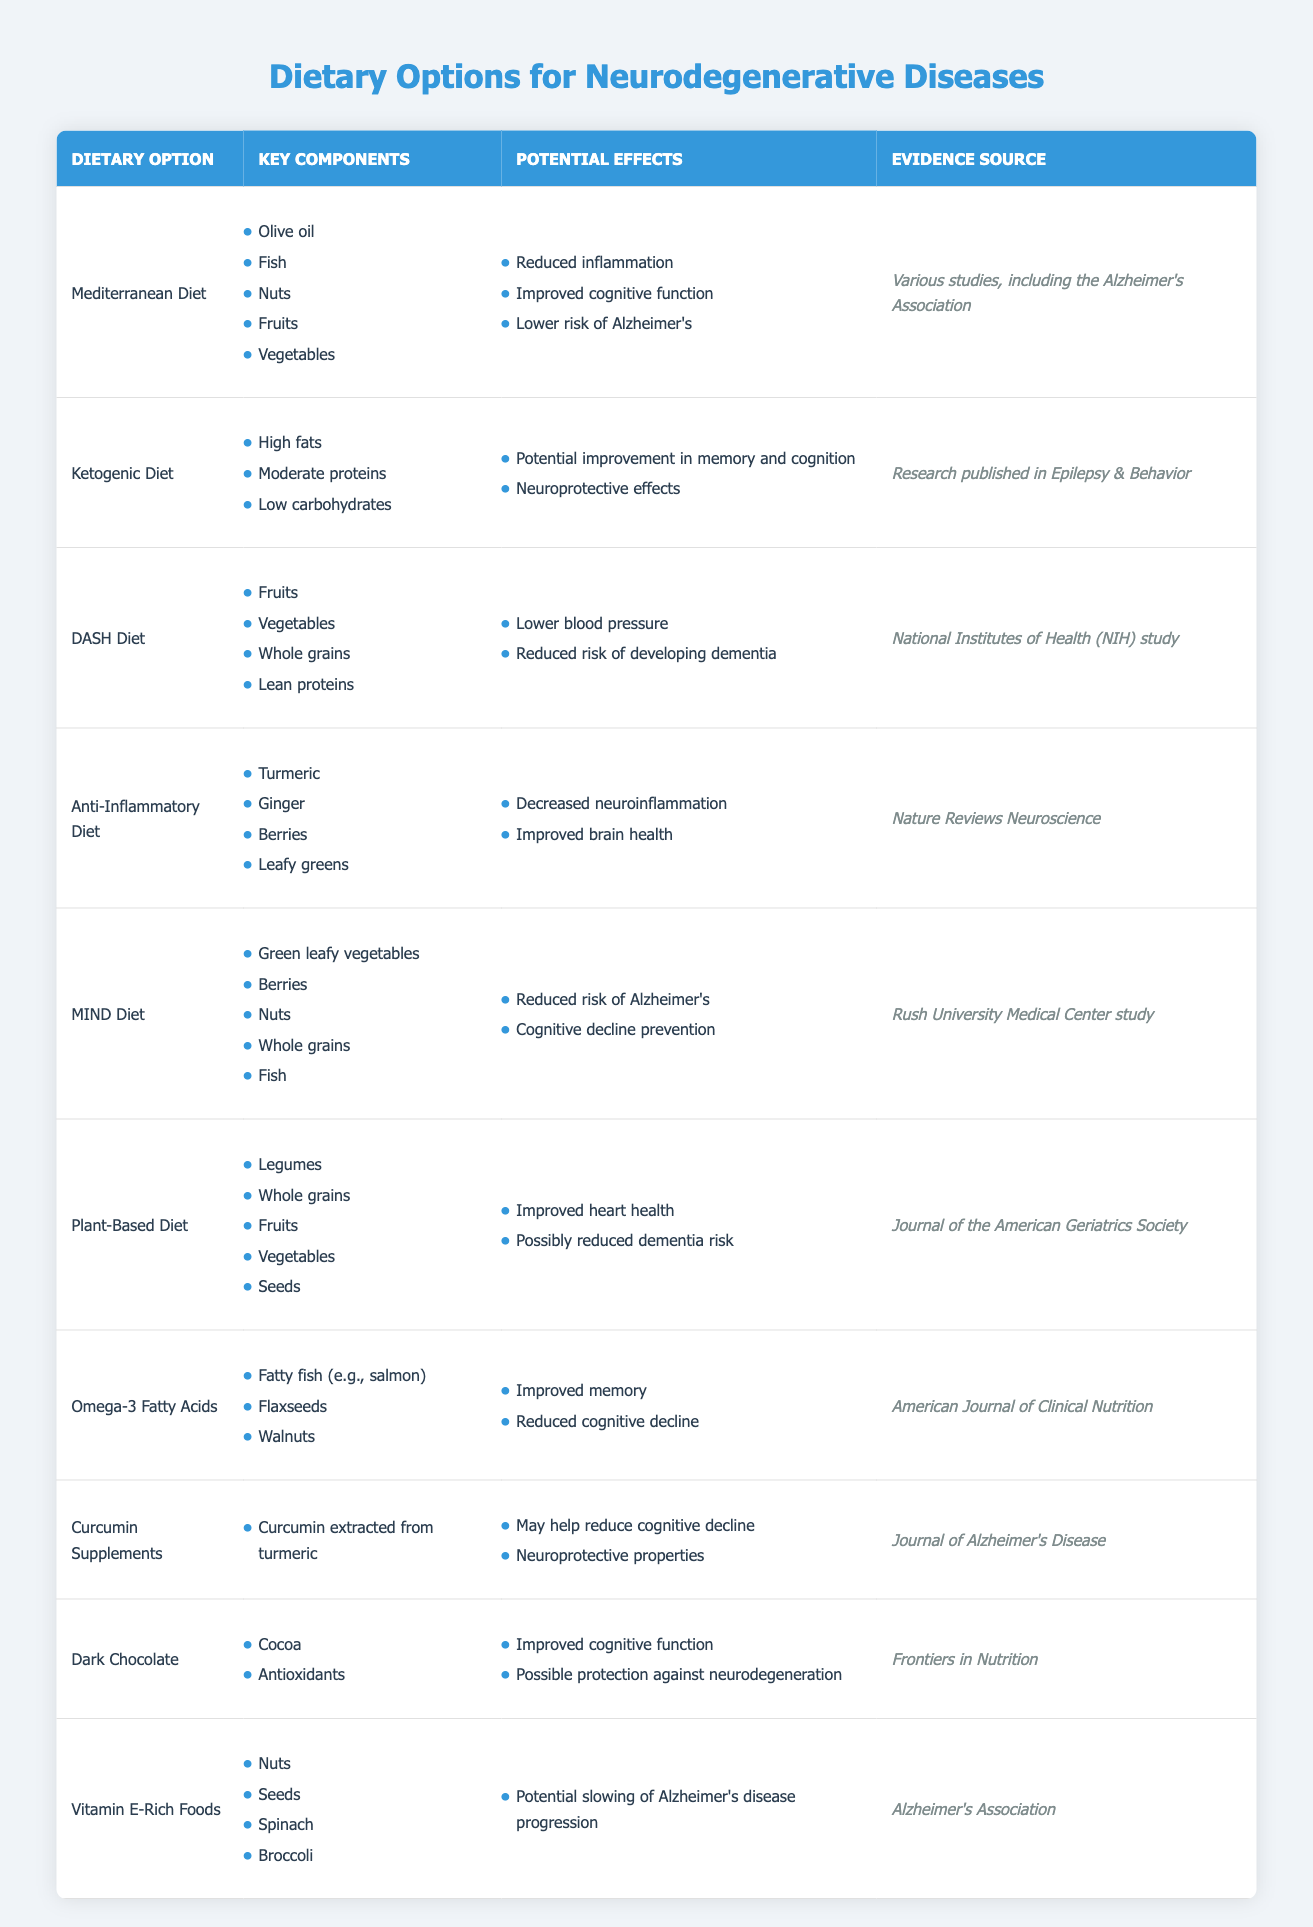What dietary option includes fish as a key component? By looking at the table, I can identify that both the Mediterranean Diet and the MIND Diet list fish in their key components.
Answer: Mediterranean Diet, MIND Diet What are the potential effects of the Anti-Inflammatory Diet? The table clearly lists the potential effects associated with the Anti-Inflammatory Diet. They are decreased neuroinflammation and improved brain health.
Answer: Decreased neuroinflammation, Improved brain health Which dietary option has a source from the National Institutes of Health? Referring to the table, the DASH Diet is the only dietary option that cites the National Institutes of Health as its evidence source.
Answer: DASH Diet True or False: The ketogenic diet is associated with improved cognitive function. Looking at the table, the potential effects listed for the Ketogenic Diet are potential improvement in memory and cognition, which indicates a true relationship.
Answer: True What dietary options are associated with a reduced risk of Alzheimer’s disease? By scanning the table, I can find that the Mediterranean Diet, MIND Diet, and Vitamin E-Rich Foods all mention a reduced risk of developing Alzheimer's disease among their potential effects.
Answer: Mediterranean Diet, MIND Diet, Vitamin E-Rich Foods Which diet includes turmeric as a key component? In the table, I can see that the Anti-Inflammatory Diet specifically lists turmeric among its key components.
Answer: Anti-Inflammatory Diet What is the average number of key components for the dietary options listed? To find the average, I first count the total number of key components listed for each dietary option. There are a total of 31 key components across 10 dietary options. Dividing 31 by 10 gives an average of 3.1.
Answer: 3.1 How many dietary options mention improved cognitive function as a potential effect? Referring to the table, the Mediterranean Diet, Ketogenic Diet, Dark Chocolate, and Curcumin Supplements all mention improved cognitive function as a potential effect, totaling four dietary options.
Answer: 4 Do any dietary options suggest a reduction in cognitive decline? Reviewing the table, both Omega-3 Fatty Acids and Curcumin Supplements list a reduction in cognitive decline as one of their potential effects. This confirms that there are some dietary options associated with this benefit.
Answer: Yes 